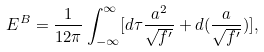<formula> <loc_0><loc_0><loc_500><loc_500>E ^ { B } = \frac { 1 } { 1 2 \pi } \int _ { - \infty } ^ { \infty } [ d \tau \frac { a ^ { 2 } } { \sqrt { f ^ { \prime } } } + d ( \frac { a } { \sqrt { f ^ { \prime } } } ) ] ,</formula> 